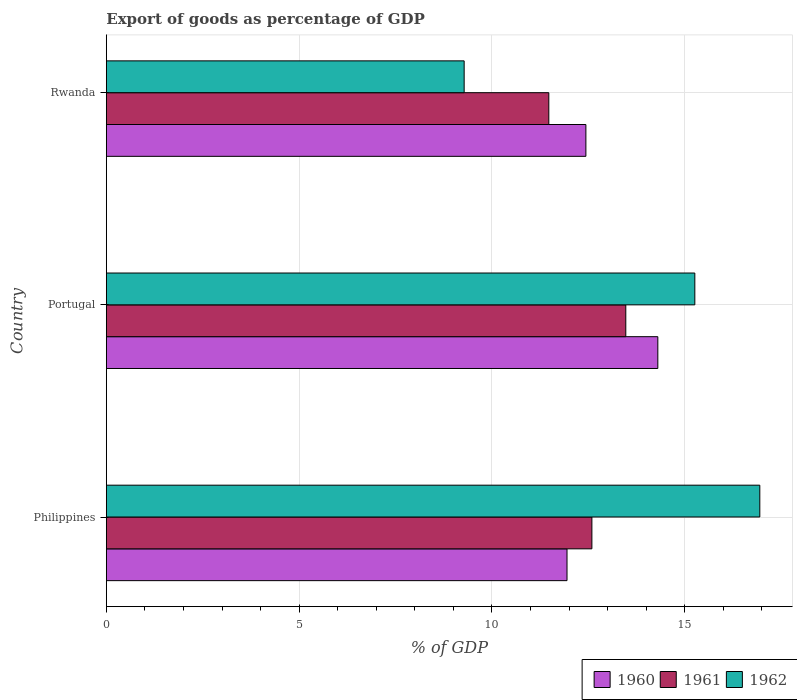How many different coloured bars are there?
Your answer should be compact. 3. Are the number of bars on each tick of the Y-axis equal?
Keep it short and to the point. Yes. How many bars are there on the 1st tick from the bottom?
Provide a succinct answer. 3. What is the label of the 1st group of bars from the top?
Your answer should be very brief. Rwanda. In how many cases, is the number of bars for a given country not equal to the number of legend labels?
Keep it short and to the point. 0. What is the export of goods as percentage of GDP in 1961 in Rwanda?
Give a very brief answer. 11.48. Across all countries, what is the maximum export of goods as percentage of GDP in 1961?
Your answer should be compact. 13.47. Across all countries, what is the minimum export of goods as percentage of GDP in 1962?
Your answer should be compact. 9.28. In which country was the export of goods as percentage of GDP in 1960 maximum?
Your answer should be very brief. Portugal. In which country was the export of goods as percentage of GDP in 1962 minimum?
Provide a short and direct response. Rwanda. What is the total export of goods as percentage of GDP in 1961 in the graph?
Provide a succinct answer. 37.54. What is the difference between the export of goods as percentage of GDP in 1961 in Philippines and that in Rwanda?
Make the answer very short. 1.12. What is the difference between the export of goods as percentage of GDP in 1962 in Rwanda and the export of goods as percentage of GDP in 1961 in Portugal?
Give a very brief answer. -4.19. What is the average export of goods as percentage of GDP in 1962 per country?
Your response must be concise. 13.83. What is the difference between the export of goods as percentage of GDP in 1961 and export of goods as percentage of GDP in 1962 in Philippines?
Your answer should be compact. -4.36. In how many countries, is the export of goods as percentage of GDP in 1961 greater than 7 %?
Make the answer very short. 3. What is the ratio of the export of goods as percentage of GDP in 1961 in Philippines to that in Rwanda?
Your answer should be compact. 1.1. Is the export of goods as percentage of GDP in 1962 in Philippines less than that in Portugal?
Offer a very short reply. No. Is the difference between the export of goods as percentage of GDP in 1961 in Portugal and Rwanda greater than the difference between the export of goods as percentage of GDP in 1962 in Portugal and Rwanda?
Give a very brief answer. No. What is the difference between the highest and the second highest export of goods as percentage of GDP in 1960?
Offer a terse response. 1.87. What is the difference between the highest and the lowest export of goods as percentage of GDP in 1960?
Provide a short and direct response. 2.36. Is the sum of the export of goods as percentage of GDP in 1960 in Philippines and Rwanda greater than the maximum export of goods as percentage of GDP in 1961 across all countries?
Make the answer very short. Yes. What does the 2nd bar from the bottom in Rwanda represents?
Give a very brief answer. 1961. Is it the case that in every country, the sum of the export of goods as percentage of GDP in 1962 and export of goods as percentage of GDP in 1960 is greater than the export of goods as percentage of GDP in 1961?
Ensure brevity in your answer.  Yes. Does the graph contain grids?
Provide a succinct answer. Yes. Where does the legend appear in the graph?
Ensure brevity in your answer.  Bottom right. How many legend labels are there?
Provide a succinct answer. 3. What is the title of the graph?
Your answer should be compact. Export of goods as percentage of GDP. Does "1967" appear as one of the legend labels in the graph?
Make the answer very short. No. What is the label or title of the X-axis?
Provide a succinct answer. % of GDP. What is the % of GDP of 1960 in Philippines?
Offer a terse response. 11.95. What is the % of GDP of 1961 in Philippines?
Provide a short and direct response. 12.59. What is the % of GDP of 1962 in Philippines?
Give a very brief answer. 16.95. What is the % of GDP in 1960 in Portugal?
Ensure brevity in your answer.  14.3. What is the % of GDP in 1961 in Portugal?
Your answer should be compact. 13.47. What is the % of GDP of 1962 in Portugal?
Your answer should be compact. 15.26. What is the % of GDP in 1960 in Rwanda?
Offer a very short reply. 12.44. What is the % of GDP in 1961 in Rwanda?
Make the answer very short. 11.48. What is the % of GDP in 1962 in Rwanda?
Offer a terse response. 9.28. Across all countries, what is the maximum % of GDP in 1960?
Ensure brevity in your answer.  14.3. Across all countries, what is the maximum % of GDP in 1961?
Your answer should be compact. 13.47. Across all countries, what is the maximum % of GDP of 1962?
Offer a terse response. 16.95. Across all countries, what is the minimum % of GDP of 1960?
Provide a succinct answer. 11.95. Across all countries, what is the minimum % of GDP of 1961?
Keep it short and to the point. 11.48. Across all countries, what is the minimum % of GDP in 1962?
Provide a succinct answer. 9.28. What is the total % of GDP of 1960 in the graph?
Make the answer very short. 38.69. What is the total % of GDP of 1961 in the graph?
Make the answer very short. 37.54. What is the total % of GDP of 1962 in the graph?
Keep it short and to the point. 41.49. What is the difference between the % of GDP in 1960 in Philippines and that in Portugal?
Your answer should be compact. -2.36. What is the difference between the % of GDP of 1961 in Philippines and that in Portugal?
Offer a very short reply. -0.88. What is the difference between the % of GDP of 1962 in Philippines and that in Portugal?
Keep it short and to the point. 1.69. What is the difference between the % of GDP in 1960 in Philippines and that in Rwanda?
Your response must be concise. -0.49. What is the difference between the % of GDP in 1961 in Philippines and that in Rwanda?
Provide a short and direct response. 1.12. What is the difference between the % of GDP in 1962 in Philippines and that in Rwanda?
Your answer should be compact. 7.67. What is the difference between the % of GDP of 1960 in Portugal and that in Rwanda?
Your answer should be very brief. 1.87. What is the difference between the % of GDP in 1961 in Portugal and that in Rwanda?
Offer a very short reply. 2. What is the difference between the % of GDP of 1962 in Portugal and that in Rwanda?
Your answer should be very brief. 5.98. What is the difference between the % of GDP in 1960 in Philippines and the % of GDP in 1961 in Portugal?
Give a very brief answer. -1.52. What is the difference between the % of GDP in 1960 in Philippines and the % of GDP in 1962 in Portugal?
Provide a short and direct response. -3.31. What is the difference between the % of GDP in 1961 in Philippines and the % of GDP in 1962 in Portugal?
Offer a very short reply. -2.67. What is the difference between the % of GDP in 1960 in Philippines and the % of GDP in 1961 in Rwanda?
Offer a terse response. 0.47. What is the difference between the % of GDP in 1960 in Philippines and the % of GDP in 1962 in Rwanda?
Provide a short and direct response. 2.67. What is the difference between the % of GDP of 1961 in Philippines and the % of GDP of 1962 in Rwanda?
Your answer should be compact. 3.31. What is the difference between the % of GDP in 1960 in Portugal and the % of GDP in 1961 in Rwanda?
Provide a short and direct response. 2.83. What is the difference between the % of GDP in 1960 in Portugal and the % of GDP in 1962 in Rwanda?
Ensure brevity in your answer.  5.02. What is the difference between the % of GDP in 1961 in Portugal and the % of GDP in 1962 in Rwanda?
Give a very brief answer. 4.19. What is the average % of GDP of 1960 per country?
Give a very brief answer. 12.9. What is the average % of GDP in 1961 per country?
Offer a terse response. 12.51. What is the average % of GDP in 1962 per country?
Your answer should be very brief. 13.83. What is the difference between the % of GDP in 1960 and % of GDP in 1961 in Philippines?
Your answer should be compact. -0.65. What is the difference between the % of GDP of 1960 and % of GDP of 1962 in Philippines?
Offer a terse response. -5. What is the difference between the % of GDP of 1961 and % of GDP of 1962 in Philippines?
Provide a short and direct response. -4.36. What is the difference between the % of GDP in 1960 and % of GDP in 1961 in Portugal?
Your response must be concise. 0.83. What is the difference between the % of GDP of 1960 and % of GDP of 1962 in Portugal?
Your response must be concise. -0.96. What is the difference between the % of GDP in 1961 and % of GDP in 1962 in Portugal?
Ensure brevity in your answer.  -1.79. What is the difference between the % of GDP in 1960 and % of GDP in 1961 in Rwanda?
Your answer should be very brief. 0.96. What is the difference between the % of GDP in 1960 and % of GDP in 1962 in Rwanda?
Your answer should be very brief. 3.16. What is the difference between the % of GDP in 1961 and % of GDP in 1962 in Rwanda?
Ensure brevity in your answer.  2.2. What is the ratio of the % of GDP in 1960 in Philippines to that in Portugal?
Provide a short and direct response. 0.84. What is the ratio of the % of GDP of 1961 in Philippines to that in Portugal?
Keep it short and to the point. 0.93. What is the ratio of the % of GDP of 1962 in Philippines to that in Portugal?
Offer a terse response. 1.11. What is the ratio of the % of GDP of 1960 in Philippines to that in Rwanda?
Provide a succinct answer. 0.96. What is the ratio of the % of GDP in 1961 in Philippines to that in Rwanda?
Your answer should be compact. 1.1. What is the ratio of the % of GDP in 1962 in Philippines to that in Rwanda?
Your answer should be very brief. 1.83. What is the ratio of the % of GDP of 1960 in Portugal to that in Rwanda?
Your response must be concise. 1.15. What is the ratio of the % of GDP of 1961 in Portugal to that in Rwanda?
Keep it short and to the point. 1.17. What is the ratio of the % of GDP in 1962 in Portugal to that in Rwanda?
Give a very brief answer. 1.64. What is the difference between the highest and the second highest % of GDP in 1960?
Offer a terse response. 1.87. What is the difference between the highest and the second highest % of GDP of 1961?
Offer a very short reply. 0.88. What is the difference between the highest and the second highest % of GDP of 1962?
Provide a succinct answer. 1.69. What is the difference between the highest and the lowest % of GDP in 1960?
Provide a succinct answer. 2.36. What is the difference between the highest and the lowest % of GDP in 1961?
Your answer should be very brief. 2. What is the difference between the highest and the lowest % of GDP of 1962?
Your answer should be very brief. 7.67. 